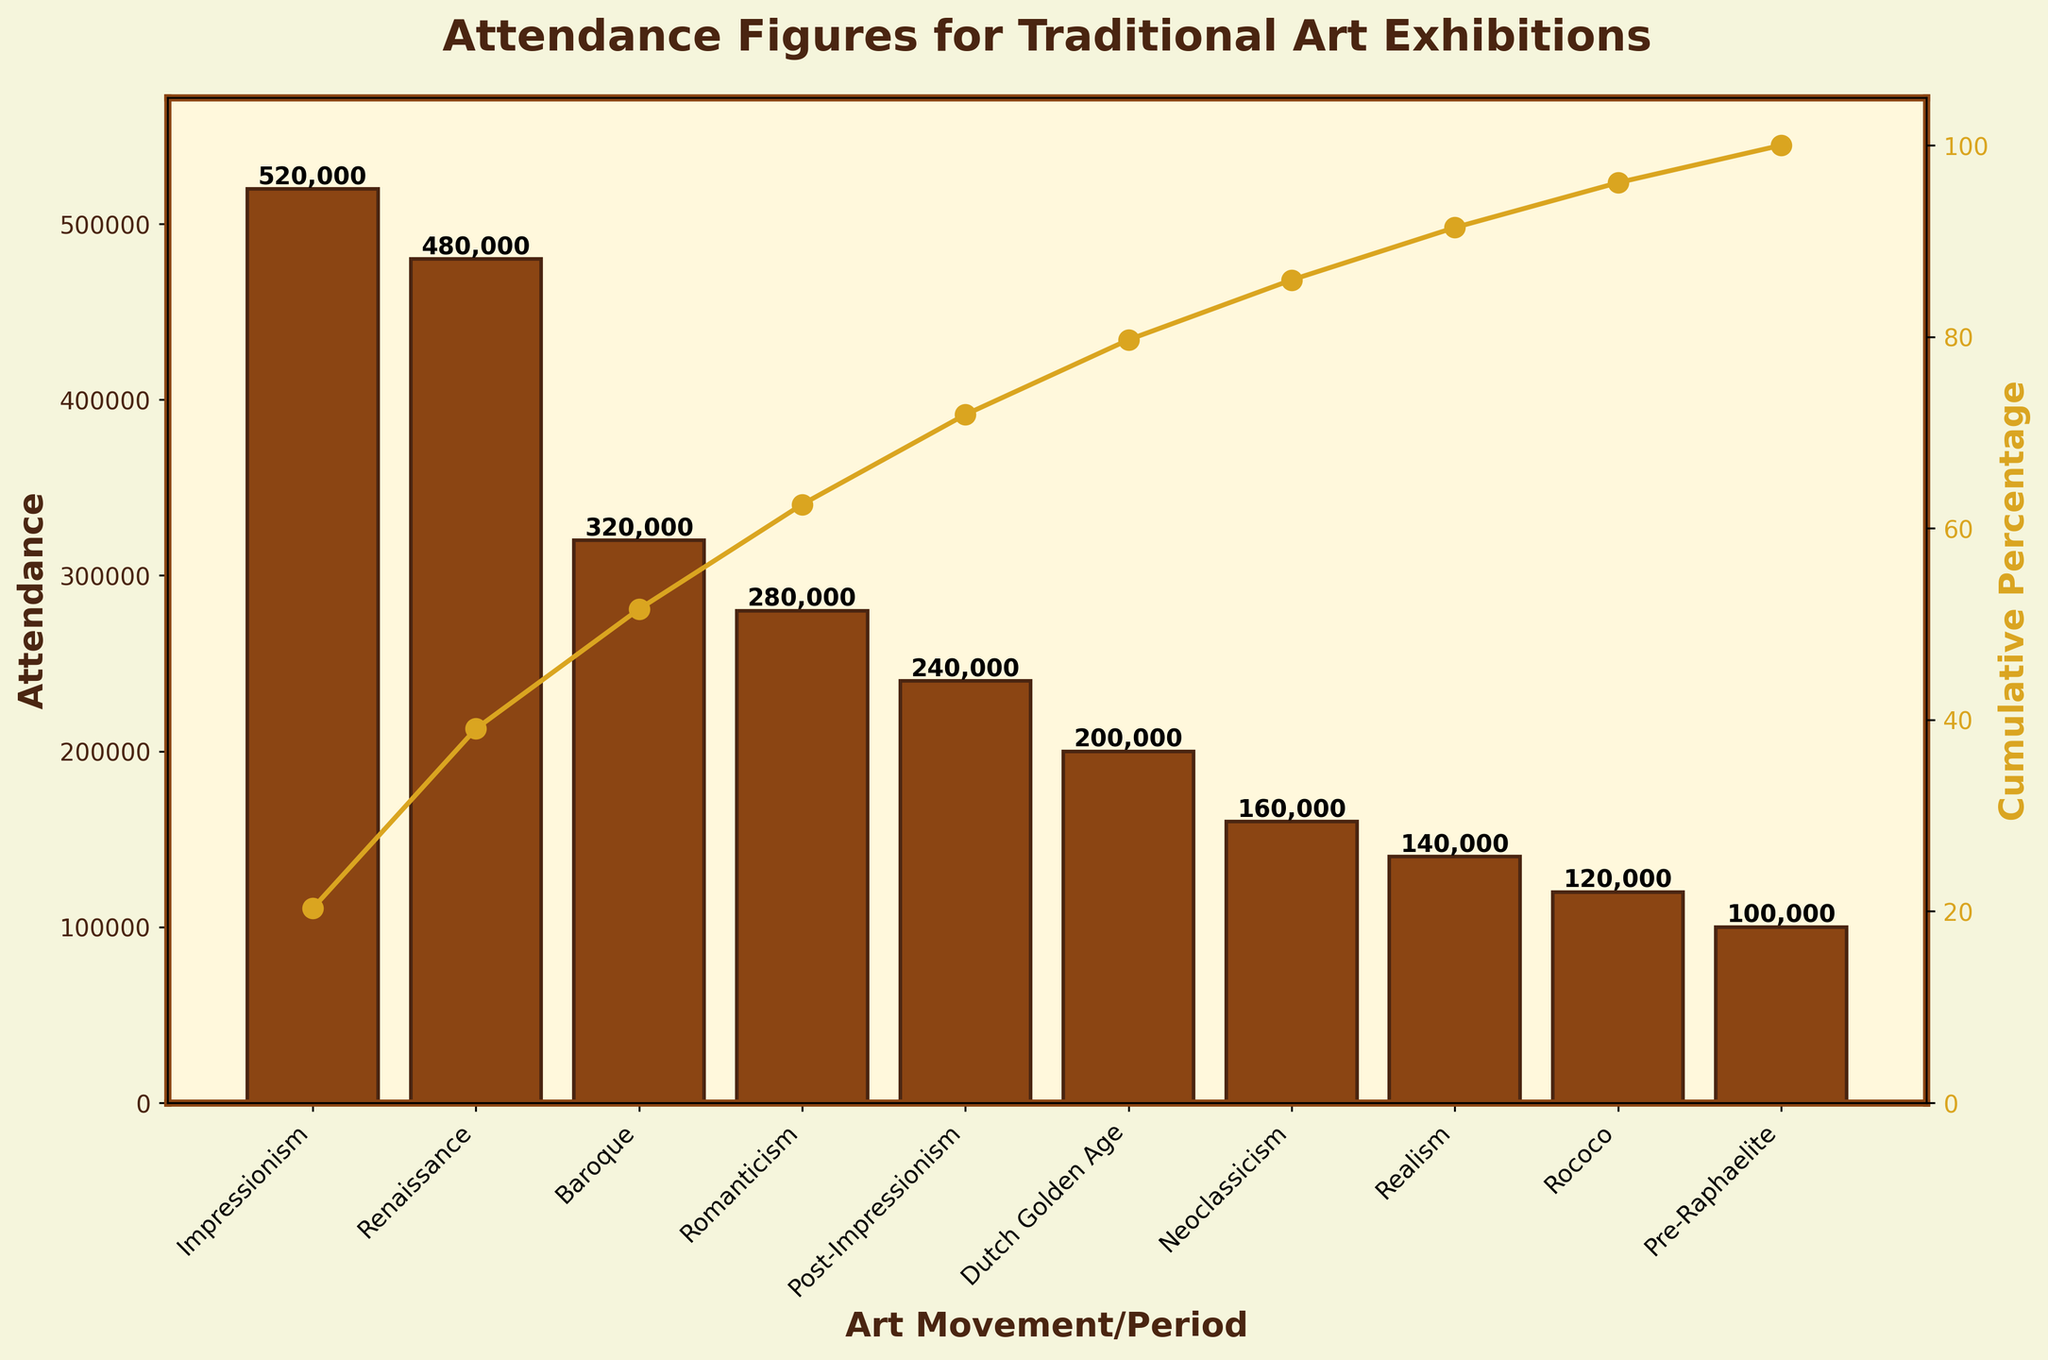Which art movement or period has the highest attendance? The bar chart shows the highest attendance figure, which is associated with the first bar. The x-axis label for this bar is "Impressionism." Therefore, Impressionism has the highest attendance.
Answer: Impressionism What is the title of the figure? The title is displayed at the top center of the figure. It reads, "Attendance Figures for Traditional Art Exhibitions."
Answer: Attendance Figures for Traditional Art Exhibitions How many art movements or periods are displayed in the chart? The x-axis of the chart has labels for each art movement or period. Counting these labels gives the total number of art movements or periods displayed. There are 10 labels, so there are 10 art movements or periods.
Answer: 10 What is the cumulative percentage for Renaissance? The cumulative percentage line intersects the "Renaissance" label at the y-axis of the secondary axis (right side). The visual value where the line intersects can be checked; for Renaissance, it is around 54%.
Answer: 54% Which art movement or period has the least attendance? The bar chart shows the lowest attendance figure, associated with the last bar. The x-axis label for this bar is "Pre-Raphaelite." Therefore, Pre-Raphaelite has the least attendance.
Answer: Pre-Raphaelite What is the cumulative percentage after combining Impressionism, Renaissance, and Baroque? First, identify the cumulative percentage for Baroque from the cumulative percentage line. It is around 85%. Since the cumulative percentage for Impressionism, Renaissance, and Baroque combined is shown at Baroque, it is approximately 85%.
Answer: 85% How does the attendance of the Baroque period compare to that of Post-Impressionism? Find the heights of the bars labeled "Baroque" and "Post-Impressionism" on the y-axis. Baroque's attendance is 320,000, whereas Post-Impressionism's attendance is 240,000. Baroque has higher attendance than Post-Impressionism.
Answer: Baroque What is the combined attendance for Neoclassicism and Realism? Locate the bars for Neoclassicism and Realism. Note their attendance figures. Neoclassicism is 160,000, and Realism is 140,000. Adding these together gives 160,000 + 140,000 = 300,000.
Answer: 300,000 Which art movements or periods account for approximately 50% of the total attendance? Look at the cumulative percentage line and find where it reaches around 50%. Impressionism and Renaissance together take us to about 54%. Therefore, these two art movements account for approximately 50% of the total attendance.
Answer: Impressionism and Renaissance What is the attendance figure for Romaniticism? Find the bar labeled "Romanticism" on the x-axis. The y-axis value at the top of the bar indicates the attendance figure, which is 280,000.
Answer: 280,000 